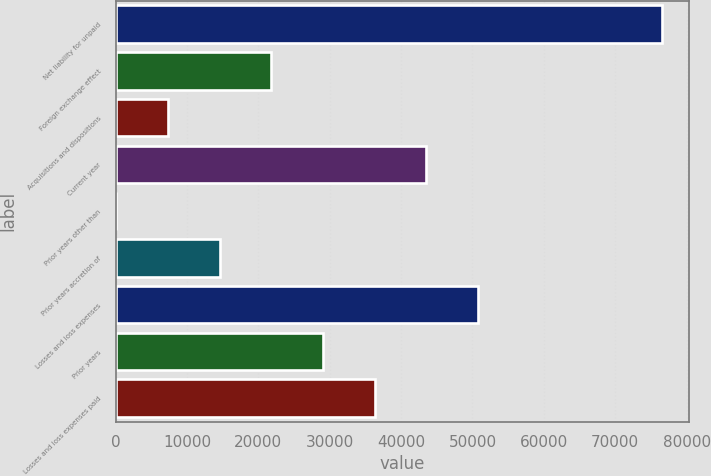Convert chart. <chart><loc_0><loc_0><loc_500><loc_500><bar_chart><fcel>Net liability for unpaid<fcel>Foreign exchange effect<fcel>Acquisitions and dispositions<fcel>Current year<fcel>Prior years other than<fcel>Prior years accretion of<fcel>Losses and loss expenses<fcel>Prior years<fcel>Losses and loss expenses paid<nl><fcel>76521.7<fcel>21819.1<fcel>7351.7<fcel>43520.2<fcel>118<fcel>14585.4<fcel>50753.9<fcel>29052.8<fcel>36286.5<nl></chart> 